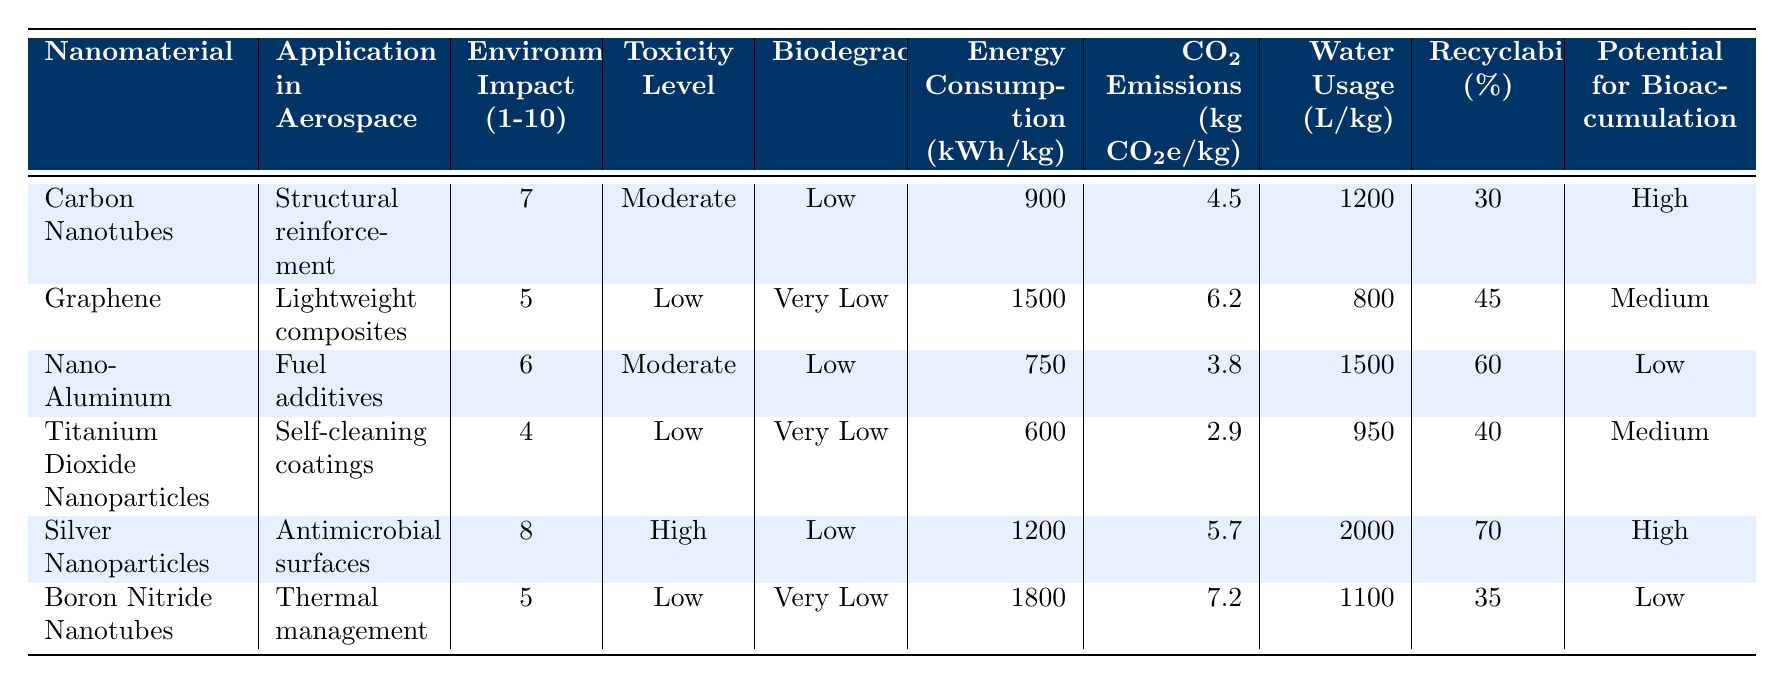What is the environmental impact rating of Silver Nanoparticles? The environmental impact rating for Silver Nanoparticles is listed in the table under the "Environmental Impact (1-10)" column, which shows the value as 8.
Answer: 8 Which nanomaterial has the lowest CO2 emissions per kilogram? By checking the CO2 emissions for each nanomaterial listed in the table, Nano-Aluminum has the lowest emissions at 3.8 kg CO2e/kg.
Answer: 3.8 kg CO2e/kg Is Titanium Dioxide Nanoparticles biodegradable? The table indicates that Titanium Dioxide Nanoparticles have "Very Low" biodegradability, which means they are not biodegradable.
Answer: No What is the average energy consumption in production for nanomaterials with a "Low" toxicity level? The energy consumption for the materials with "Low" toxicity is 1500 (Graphene), 600 (Titanium Dioxide Nanoparticles), and 1800 (Boron Nitride Nanotubes). The average is calculated as (1500 + 600 + 1800) / 3 = 966.67 kWh/kg.
Answer: 966.67 kWh/kg Which nanomaterial has the highest potential for bioaccumulation? The potential for bioaccumulation for each material is examined, and both Carbon Nanotubes and Silver Nanoparticles have "High" potential. The question confirms that at least one nanomaterial is categorized as high.
Answer: Yes What is the recyclability percentage of Nano-Aluminum? The recyclability percentage for Nano-Aluminum is found under the "Recyclability (%)" column, which states it is 60%.
Answer: 60% How many liters of water are used per kilogram to produce Silver Nanoparticles? The table indicates that the water usage for producing Silver Nanoparticles is 2000 liters per kilogram, which directly answers the question.
Answer: 2000 L/kg Which nanomaterial has the highest environmental impact rating and what is it? By reviewing the environmental impact ratings for each nanomaterial, Silver Nanoparticles lead with the highest rating of 8, confirming it to be the highest in environmental impact.
Answer: Silver Nanoparticles, 8 Which nanomaterial would require the most energy to produce, and how much? The energy consumption values listed in the table are considered, where Boron Nitride Nanotubes require 1800 kWh/kg for production, making it the highest energy requirement among the materials.
Answer: Boron Nitride Nanotubes, 1800 kWh/kg 